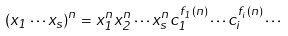<formula> <loc_0><loc_0><loc_500><loc_500>( x _ { 1 } \cdots x _ { s } ) ^ { n } = x _ { 1 } ^ { n } x _ { 2 } ^ { n } \cdots x _ { s } ^ { n } c _ { 1 } ^ { f _ { 1 } ( n ) } \cdots c _ { i } ^ { f _ { i } ( n ) } \cdots</formula> 